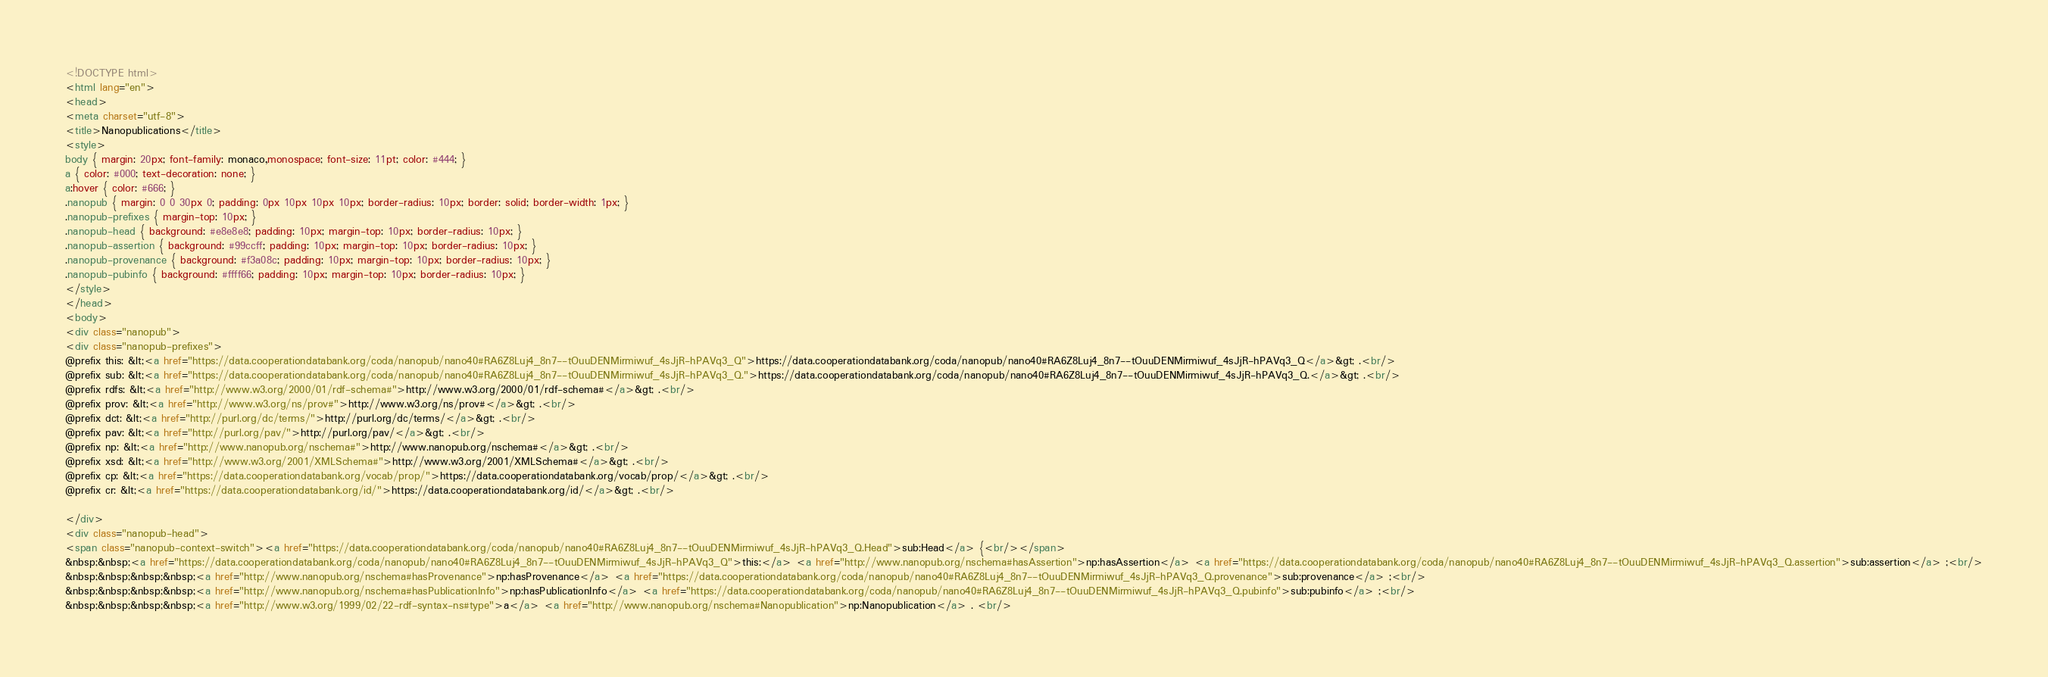<code> <loc_0><loc_0><loc_500><loc_500><_HTML_><!DOCTYPE html>
<html lang="en">
<head>
<meta charset="utf-8">
<title>Nanopublications</title>
<style>
body { margin: 20px; font-family: monaco,monospace; font-size: 11pt; color: #444; }
a { color: #000; text-decoration: none; }
a:hover { color: #666; }
.nanopub { margin: 0 0 30px 0; padding: 0px 10px 10px 10px; border-radius: 10px; border: solid; border-width: 1px; }
.nanopub-prefixes { margin-top: 10px; }
.nanopub-head { background: #e8e8e8; padding: 10px; margin-top: 10px; border-radius: 10px; }
.nanopub-assertion { background: #99ccff; padding: 10px; margin-top: 10px; border-radius: 10px; }
.nanopub-provenance { background: #f3a08c; padding: 10px; margin-top: 10px; border-radius: 10px; }
.nanopub-pubinfo { background: #ffff66; padding: 10px; margin-top: 10px; border-radius: 10px; }
</style>
</head>
<body>
<div class="nanopub">
<div class="nanopub-prefixes">
@prefix this: &lt;<a href="https://data.cooperationdatabank.org/coda/nanopub/nano40#RA6Z8Luj4_8n7--tOuuDENMirmiwuf_4sJjR-hPAVq3_Q">https://data.cooperationdatabank.org/coda/nanopub/nano40#RA6Z8Luj4_8n7--tOuuDENMirmiwuf_4sJjR-hPAVq3_Q</a>&gt; .<br/>
@prefix sub: &lt;<a href="https://data.cooperationdatabank.org/coda/nanopub/nano40#RA6Z8Luj4_8n7--tOuuDENMirmiwuf_4sJjR-hPAVq3_Q.">https://data.cooperationdatabank.org/coda/nanopub/nano40#RA6Z8Luj4_8n7--tOuuDENMirmiwuf_4sJjR-hPAVq3_Q.</a>&gt; .<br/>
@prefix rdfs: &lt;<a href="http://www.w3.org/2000/01/rdf-schema#">http://www.w3.org/2000/01/rdf-schema#</a>&gt; .<br/>
@prefix prov: &lt;<a href="http://www.w3.org/ns/prov#">http://www.w3.org/ns/prov#</a>&gt; .<br/>
@prefix dct: &lt;<a href="http://purl.org/dc/terms/">http://purl.org/dc/terms/</a>&gt; .<br/>
@prefix pav: &lt;<a href="http://purl.org/pav/">http://purl.org/pav/</a>&gt; .<br/>
@prefix np: &lt;<a href="http://www.nanopub.org/nschema#">http://www.nanopub.org/nschema#</a>&gt; .<br/>
@prefix xsd: &lt;<a href="http://www.w3.org/2001/XMLSchema#">http://www.w3.org/2001/XMLSchema#</a>&gt; .<br/>
@prefix cp: &lt;<a href="https://data.cooperationdatabank.org/vocab/prop/">https://data.cooperationdatabank.org/vocab/prop/</a>&gt; .<br/>
@prefix cr: &lt;<a href="https://data.cooperationdatabank.org/id/">https://data.cooperationdatabank.org/id/</a>&gt; .<br/>

</div>
<div class="nanopub-head">
<span class="nanopub-context-switch"><a href="https://data.cooperationdatabank.org/coda/nanopub/nano40#RA6Z8Luj4_8n7--tOuuDENMirmiwuf_4sJjR-hPAVq3_Q.Head">sub:Head</a> {<br/></span>
&nbsp;&nbsp;<a href="https://data.cooperationdatabank.org/coda/nanopub/nano40#RA6Z8Luj4_8n7--tOuuDENMirmiwuf_4sJjR-hPAVq3_Q">this:</a> <a href="http://www.nanopub.org/nschema#hasAssertion">np:hasAssertion</a> <a href="https://data.cooperationdatabank.org/coda/nanopub/nano40#RA6Z8Luj4_8n7--tOuuDENMirmiwuf_4sJjR-hPAVq3_Q.assertion">sub:assertion</a> ;<br/>
&nbsp;&nbsp;&nbsp;&nbsp;<a href="http://www.nanopub.org/nschema#hasProvenance">np:hasProvenance</a> <a href="https://data.cooperationdatabank.org/coda/nanopub/nano40#RA6Z8Luj4_8n7--tOuuDENMirmiwuf_4sJjR-hPAVq3_Q.provenance">sub:provenance</a> ;<br/>
&nbsp;&nbsp;&nbsp;&nbsp;<a href="http://www.nanopub.org/nschema#hasPublicationInfo">np:hasPublicationInfo</a> <a href="https://data.cooperationdatabank.org/coda/nanopub/nano40#RA6Z8Luj4_8n7--tOuuDENMirmiwuf_4sJjR-hPAVq3_Q.pubinfo">sub:pubinfo</a> ;<br/>
&nbsp;&nbsp;&nbsp;&nbsp;<a href="http://www.w3.org/1999/02/22-rdf-syntax-ns#type">a</a> <a href="http://www.nanopub.org/nschema#Nanopublication">np:Nanopublication</a> . <br/></code> 